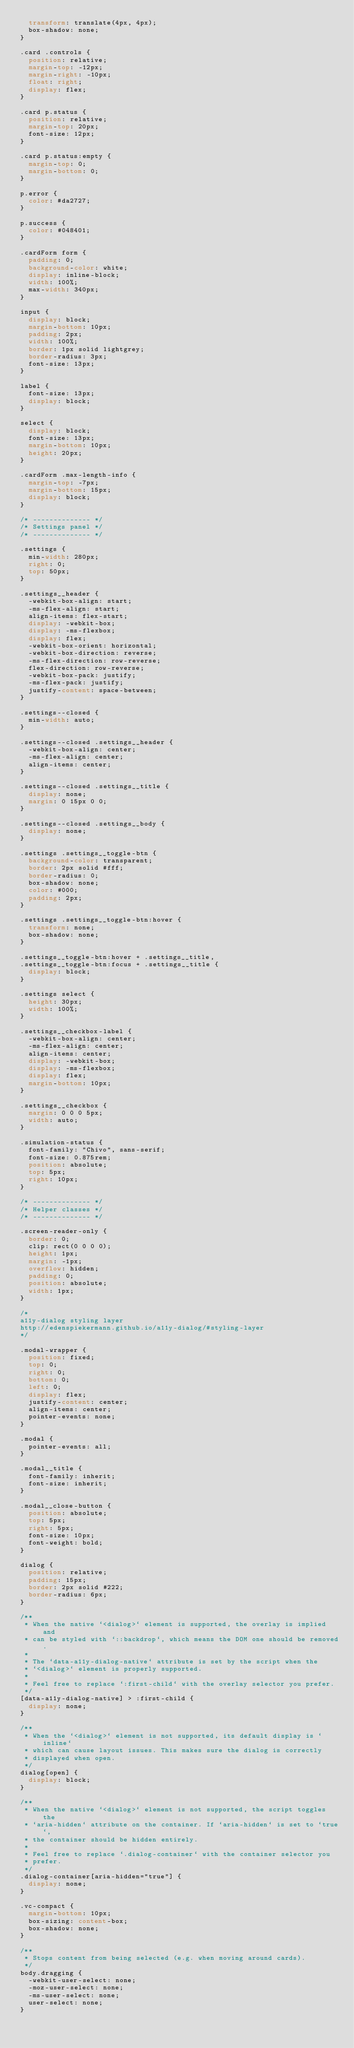<code> <loc_0><loc_0><loc_500><loc_500><_CSS_>  transform: translate(4px, 4px);
  box-shadow: none;
}

.card .controls {
  position: relative;
  margin-top: -12px;
  margin-right: -10px;
  float: right;
  display: flex;
}

.card p.status {
  position: relative;
  margin-top: 20px;
  font-size: 12px;
}

.card p.status:empty {
  margin-top: 0;
  margin-bottom: 0;
}

p.error {
  color: #da2727;
}

p.success {
  color: #048401;
}

.cardForm form {
  padding: 0;
  background-color: white;
  display: inline-block;
  width: 100%;
  max-width: 340px;
}

input {
  display: block;
  margin-bottom: 10px;
  padding: 2px;
  width: 100%;
  border: 1px solid lightgrey;
  border-radius: 3px;
  font-size: 13px;
}

label {
  font-size: 13px;
  display: block;
}

select {
  display: block;
  font-size: 13px;
  margin-bottom: 10px;
  height: 20px;
}

.cardForm .max-length-info {
  margin-top: -7px;
  margin-bottom: 15px;
  display: block;
}

/* -------------- */
/* Settings panel */
/* -------------- */

.settings {
  min-width: 280px;
  right: 0;
  top: 50px;
}

.settings__header {
  -webkit-box-align: start;
  -ms-flex-align: start;
  align-items: flex-start;
  display: -webkit-box;
  display: -ms-flexbox;
  display: flex;
  -webkit-box-orient: horizontal;
  -webkit-box-direction: reverse;
  -ms-flex-direction: row-reverse;
  flex-direction: row-reverse;
  -webkit-box-pack: justify;
  -ms-flex-pack: justify;
  justify-content: space-between;
}

.settings--closed {
  min-width: auto;
}

.settings--closed .settings__header {
  -webkit-box-align: center;
  -ms-flex-align: center;
  align-items: center;
}

.settings--closed .settings__title {
  display: none;
  margin: 0 15px 0 0;
}

.settings--closed .settings__body {
  display: none;
}

.settings .settings__toggle-btn {
  background-color: transparent;
  border: 2px solid #fff;
  border-radius: 0;
  box-shadow: none;
  color: #000;
  padding: 2px;
}

.settings .settings__toggle-btn:hover {
  transform: none;
  box-shadow: none;
}

.settings__toggle-btn:hover + .settings__title,
.settings__toggle-btn:focus + .settings__title {
  display: block;
}

.settings select {
  height: 30px;
  width: 100%;
}

.settings__checkbox-label {
  -webkit-box-align: center;
  -ms-flex-align: center;
  align-items: center;
  display: -webkit-box;
  display: -ms-flexbox;
  display: flex;
  margin-bottom: 10px;
}

.settings__checkbox {
  margin: 0 0 0 5px;
  width: auto;
}

.simulation-status {
  font-family: "Chivo", sans-serif;
  font-size: 0.875rem;
  position: absolute;
  top: 5px;
  right: 10px;
}

/* -------------- */
/* Helper classes */
/* -------------- */

.screen-reader-only {
  border: 0;
  clip: rect(0 0 0 0);
  height: 1px;
  margin: -1px;
  overflow: hidden;
  padding: 0;
  position: absolute;
  width: 1px;
}

/*
a11y-dialog styling layer
http://edenspiekermann.github.io/a11y-dialog/#styling-layer
*/

.modal-wrapper {
  position: fixed;
  top: 0;
  right: 0;
  bottom: 0;
  left: 0;
  display: flex;
  justify-content: center;
  align-items: center;
  pointer-events: none;
}

.modal {
  pointer-events: all;
}

.modal__title {
  font-family: inherit;
  font-size: inherit;
}

.modal__close-button {
  position: absolute;
  top: 5px;
  right: 5px;
  font-size: 10px;
  font-weight: bold;
}

dialog {
  position: relative;
  padding: 15px;
  border: 2px solid #222;
  border-radius: 6px;
}

/**
 * When the native `<dialog>` element is supported, the overlay is implied and
 * can be styled with `::backdrop`, which means the DOM one should be removed.
 *
 * The `data-a11y-dialog-native` attribute is set by the script when the
 * `<dialog>` element is properly supported.
 *
 * Feel free to replace `:first-child` with the overlay selector you prefer.
 */
[data-a11y-dialog-native] > :first-child {
  display: none;
}

/**
 * When the `<dialog>` element is not supported, its default display is `inline`
 * which can cause layout issues. This makes sure the dialog is correctly
 * displayed when open.
 */
dialog[open] {
  display: block;
}

/**
 * When the native `<dialog>` element is not supported, the script toggles the
 * `aria-hidden` attribute on the container. If `aria-hidden` is set to `true`,
 * the container should be hidden entirely.
 *
 * Feel free to replace `.dialog-container` with the container selector you
 * prefer.
 */
.dialog-container[aria-hidden="true"] {
  display: none;
}

.vc-compact {
  margin-bottom: 10px;
  box-sizing: content-box;
  box-shadow: none;
}

/**
 * Stops content from being selected (e.g. when moving around cards).
 */
body.dragging {
  -webkit-user-select: none;
  -moz-user-select: none;
  -ms-user-select: none;
  user-select: none;
}
</code> 